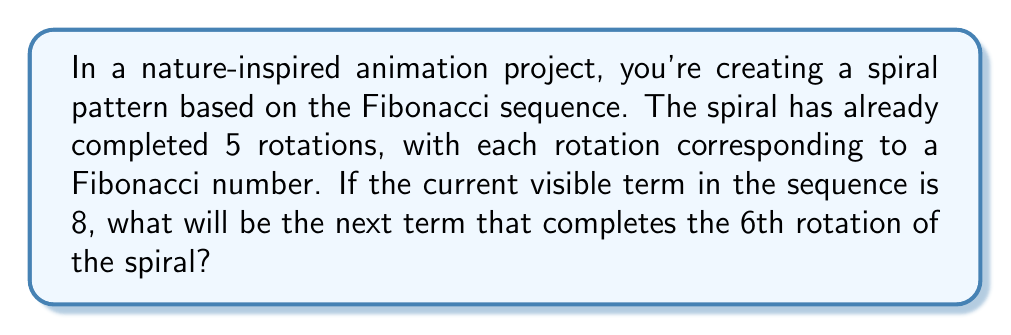Can you answer this question? To solve this problem, let's follow these steps:

1) First, recall the Fibonacci sequence:
   $$1, 1, 2, 3, 5, 8, 13, 21, 34, 55, ...$$

2) Each number in the sequence is the sum of the two preceding ones.

3) We're told that the current visible term is 8, which corresponds to the 5th rotation of the spiral.

4) To find the next term, we need to identify the two preceding terms in the sequence:
   $$..., 5, 8, ?$$

5) The term before 8 is 5.

6) To calculate the next term, we add the current term (8) and the previous term (5):
   $$8 + 5 = 13$$

7) Therefore, the next term in the sequence, which will complete the 6th rotation of the spiral, is 13.

This can be visualized as follows:

[asy]
unitsize(10mm);
pair z0=(0,0);
pair z1=(1,0);
pair z2=(1,1);
pair z3=(0,1);
pair z4=(-1,1);
pair z5=(-1,0);
pair z6=(-1,-1);
draw(z0--z1--z2--z3--z4--z5--z6,blue+1);
label("1",z0,SE);
label("1",z1,NE);
label("2",z2,NW);
label("3",z3,SW);
label("5",z4,SE);
label("8",z5,NE);
label("13",z6,NW);
[/asy]

In this diagram, each arc represents a term in the Fibonacci sequence, with the length of the arc proportional to the term's value. The next arc would extend the spiral further, representing the term 13.
Answer: 13 